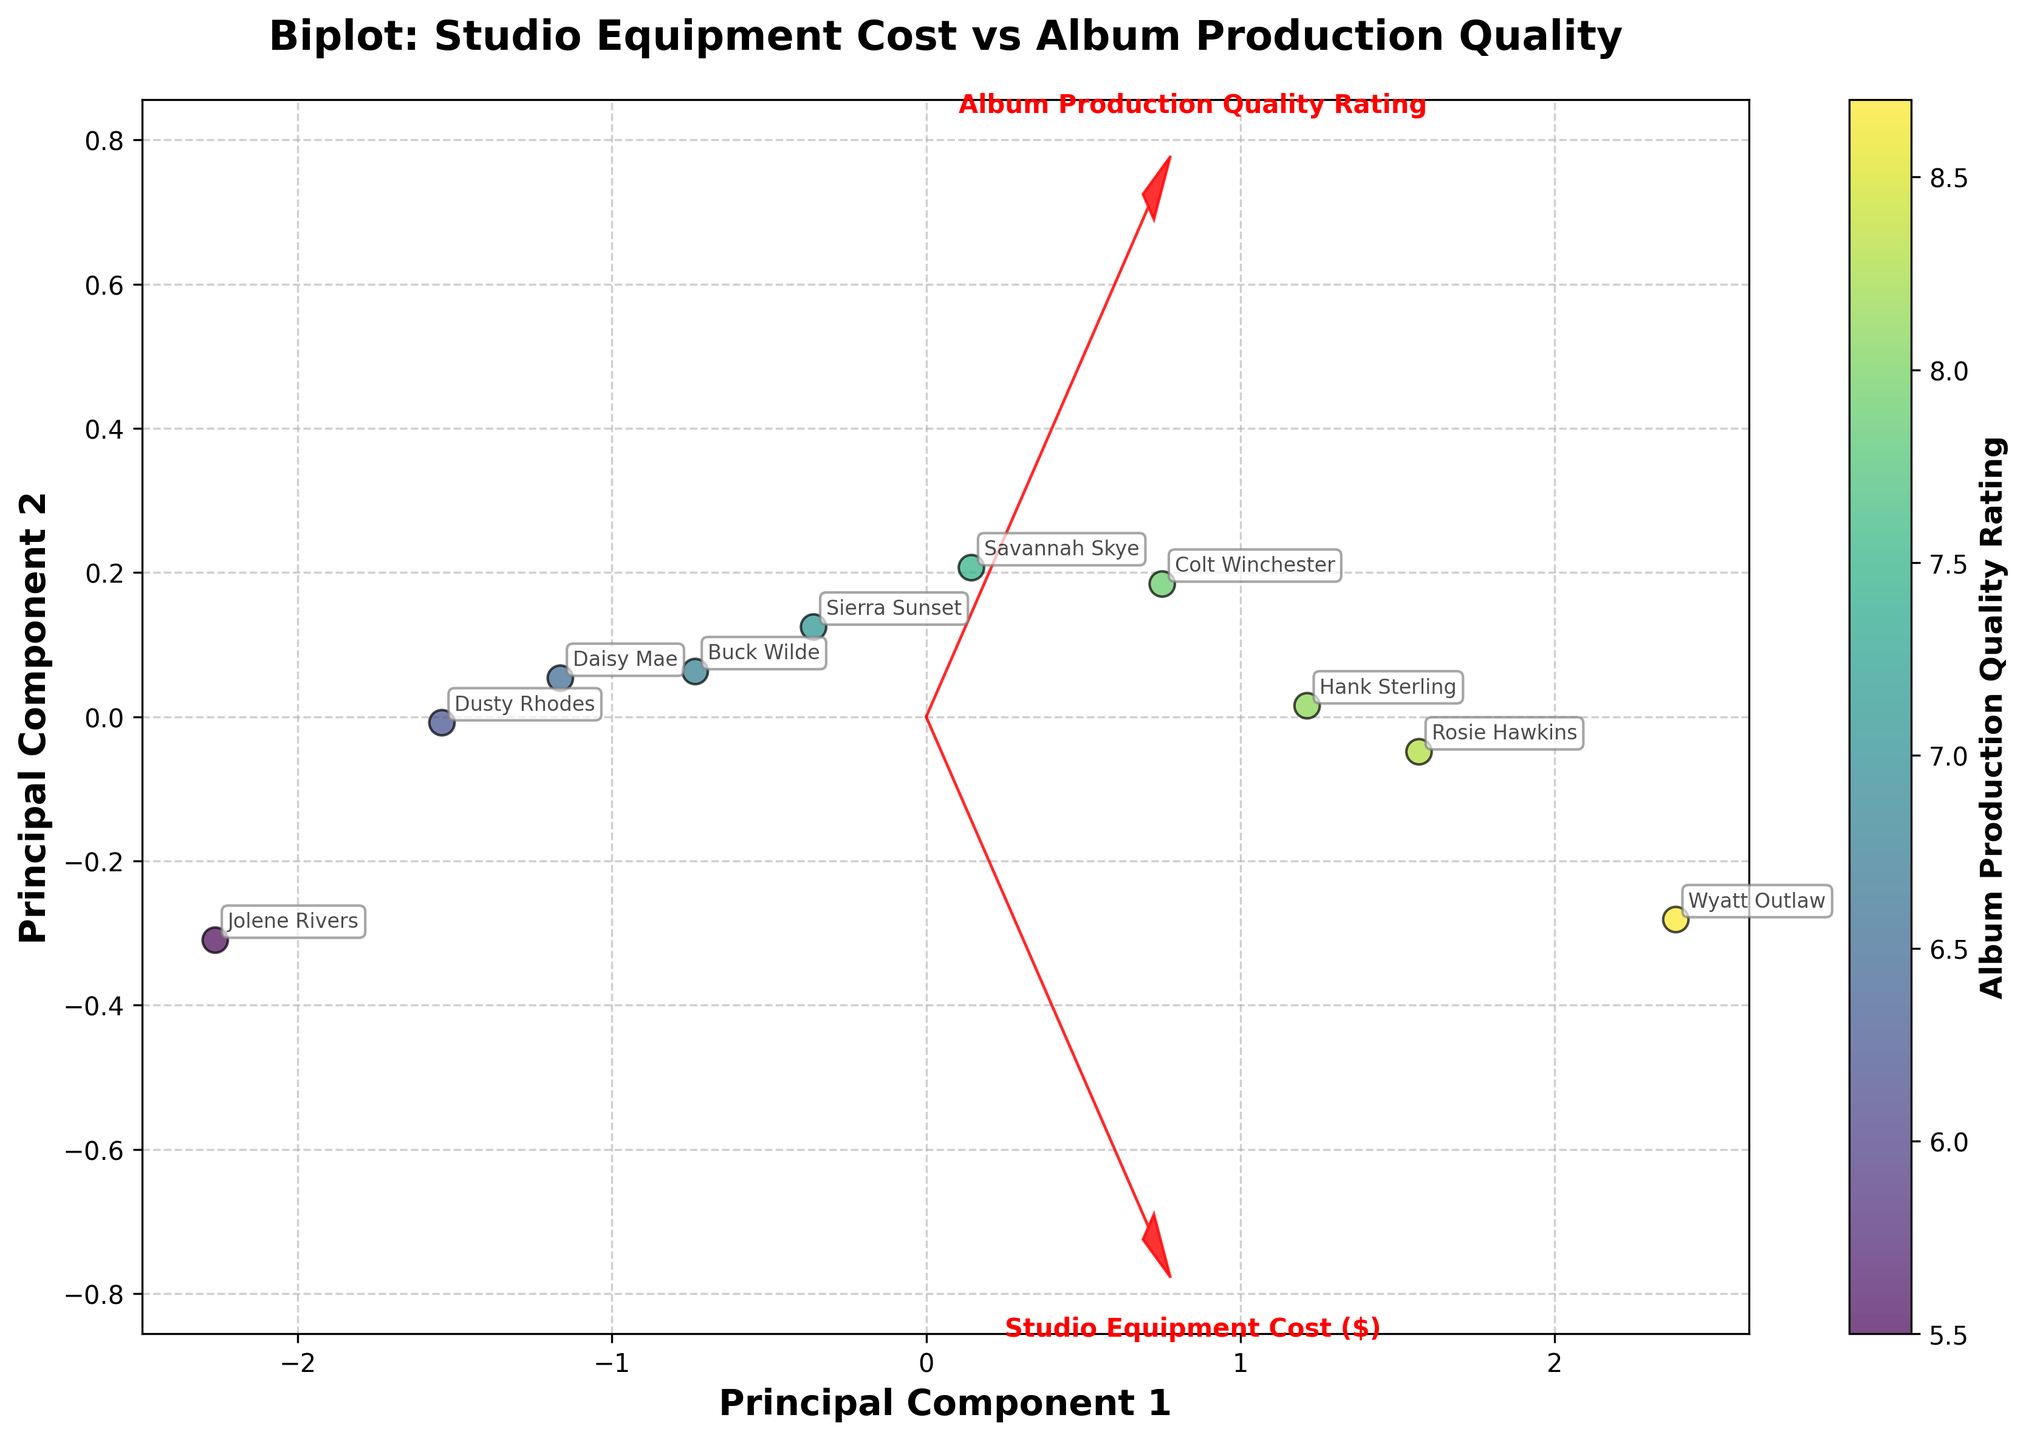What is the title of the figure? The title of the figure is usually located at the top center of the plot. Since the plot focuses on the correlation between studio equipment costs and album production quality ratings, the title should directly indicate this relationship. Looking at the top of the figure, we see the title.
Answer: Biplot: Studio Equipment Cost vs Album Production Quality How many data points are shown in the scatter plot? The number of data points is equal to the number of artists/albums listed. We can count the individual points or annotations representing each artist. From the figure, we see 10 distinct points.
Answer: 10 Which artist has the highest album production quality rating? To identify the artist with the highest rating, we need to look at the color gradient in the scatter plot or the annotations for the highest rating. The artist with the highest annotated rating is identified.
Answer: Wyatt Outlaw Is there a positive correlation between studio equipment cost and album production quality rating? To determine the correlation, observe the overall direction of data points. If they trend from the bottom left to the top right, it indicates a positive correlation. Given the spread of data points in the figure, they generally follow this pattern.
Answer: Yes Which two features are represented as vectors in the biplot? The biplot shows two vectors originating from the origin (0,0), each representing a feature. The labels along these vectors indicate the features. In the figure, the vectors represent 'Studio Equipment Cost ($)' and 'Album Production Quality Rating.'
Answer: Studio Equipment Cost ($) and Album Production Quality Rating Which artist has the lowest studio equipment cost? To find the artist with the lowest studio equipment cost, look for the label closest to the origin on the axis representing this feature (Studio Equipment Cost ($)). The scatter plot points and labels will guide you to this information.
Answer: Jolene Rivers What is the approximate range of the studio equipment costs in the figure? The range is determined by subtracting the lowest equipment cost from the highest. By looking at the scatter plot points representing the studio equipment costs, we see the lowest is around $3000 and the highest is around $25000. Therefore, the range is $\$25000 - \$3000 = \$22000$.
Answer: $22000 Which feature contributes more to Principal Component 1 based on the length of the vectors? In a biplot, the feature with a longer projection along the Principal Component 1 axis contributes more to this component. Comparing the lengths of the vectors for 'Studio Equipment Cost ($)' and 'Album Production Quality Rating,' we see which one extends further along PC1.
Answer: Studio Equipment Cost ($) How does the album production quality rating of Dusty Rhodes compare to Hank Sterling? By locating the annotations for Dusty Rhodes and Hank Sterling, we compare their respective rating colors and positions. Dusty Rhodes has a rating indicated by a lighter dot compared to a darker dot for Hank Sterling, implying a lower rating.
Answer: Lower What does the scatter plot reveal about the overall relationship between spending on studio equipment and album quality for these artists? The scatter plot shows the pattern of data points trending from lower-left to upper-right, suggesting that higher studio equipment costs are generally associated with higher album production quality ratings, revealing a positive correlation.
Answer: Higher spending tends to be associated with higher quality 